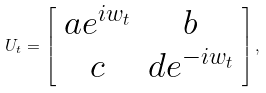<formula> <loc_0><loc_0><loc_500><loc_500>U _ { t } = \left [ \begin{array} { c c } a e ^ { i w _ { t } } & b \\ c & d e ^ { - i w _ { t } } \end{array} \right ] ,</formula> 